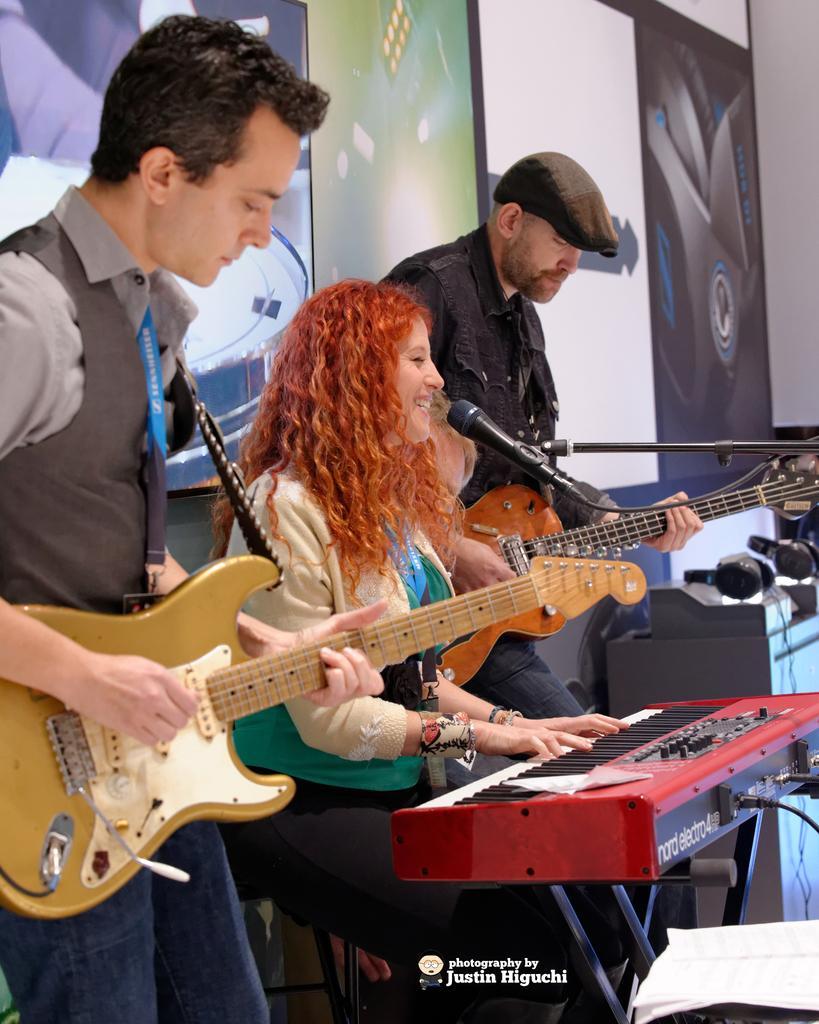Could you give a brief overview of what you see in this image? Here we can see 3 people, the first person in the left is standing and he is playing guitar the second person is playing a piano and she has a microphone in front of her that third person is also playing a guitar 